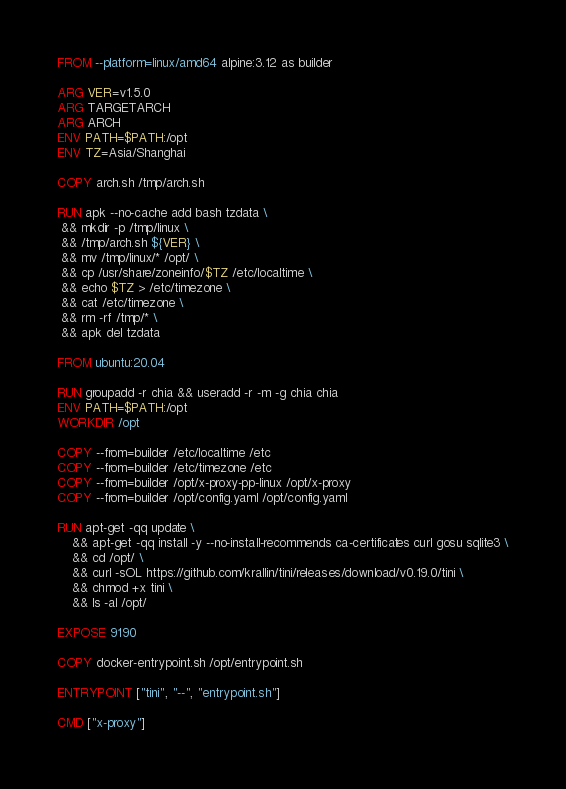Convert code to text. <code><loc_0><loc_0><loc_500><loc_500><_Dockerfile_>FROM --platform=linux/amd64 alpine:3.12 as builder

ARG VER=v1.5.0
ARG TARGETARCH
ARG ARCH
ENV PATH=$PATH:/opt
ENV TZ=Asia/Shanghai

COPY arch.sh /tmp/arch.sh

RUN apk --no-cache add bash tzdata \
 && mkdir -p /tmp/linux \
 && /tmp/arch.sh ${VER} \
 && mv /tmp/linux/* /opt/ \
 && cp /usr/share/zoneinfo/$TZ /etc/localtime \
 && echo $TZ > /etc/timezone \
 && cat /etc/timezone \
 && rm -rf /tmp/* \
 && apk del tzdata

FROM ubuntu:20.04

RUN groupadd -r chia && useradd -r -m -g chia chia
ENV PATH=$PATH:/opt
WORKDIR /opt

COPY --from=builder /etc/localtime /etc
COPY --from=builder /etc/timezone /etc
COPY --from=builder /opt/x-proxy-pp-linux /opt/x-proxy
COPY --from=builder /opt/config.yaml /opt/config.yaml

RUN apt-get -qq update \
    && apt-get -qq install -y --no-install-recommends ca-certificates curl gosu sqlite3 \
    && cd /opt/ \
    && curl -sOL https://github.com/krallin/tini/releases/download/v0.19.0/tini \
    && chmod +x tini \
    && ls -al /opt/

EXPOSE 9190

COPY docker-entrypoint.sh /opt/entrypoint.sh

ENTRYPOINT ["tini", "--", "entrypoint.sh"]

CMD ["x-proxy"]
</code> 